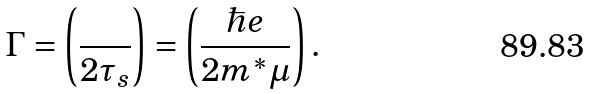Convert formula to latex. <formula><loc_0><loc_0><loc_500><loc_500>\Gamma = \left ( \frac { } { 2 \tau _ { s } } \right ) = \left ( \frac { \hbar { e } } { 2 m ^ { * } \mu } \right ) .</formula> 